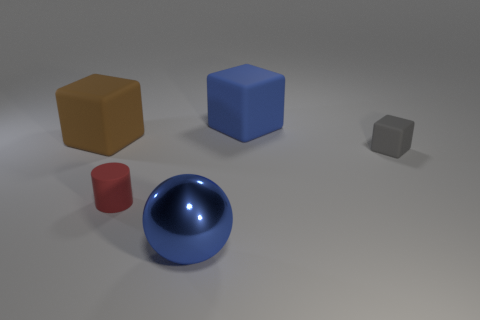Is the number of red spheres less than the number of blocks?
Provide a succinct answer. Yes. Does the small cube have the same material as the cylinder?
Your response must be concise. Yes. What number of other things are there of the same color as the small cylinder?
Give a very brief answer. 0. Is the number of small red things greater than the number of red cubes?
Provide a short and direct response. Yes. There is a blue metallic thing; does it have the same size as the rubber cylinder behind the metallic ball?
Make the answer very short. No. There is a rubber object that is behind the brown block; what color is it?
Your response must be concise. Blue. How many green objects are either matte cylinders or large metallic objects?
Make the answer very short. 0. What is the color of the ball?
Make the answer very short. Blue. Is there anything else that has the same material as the big blue sphere?
Provide a succinct answer. No. Is the number of small red matte cylinders that are behind the red rubber cylinder less than the number of big brown things that are behind the big brown matte cube?
Give a very brief answer. No. 